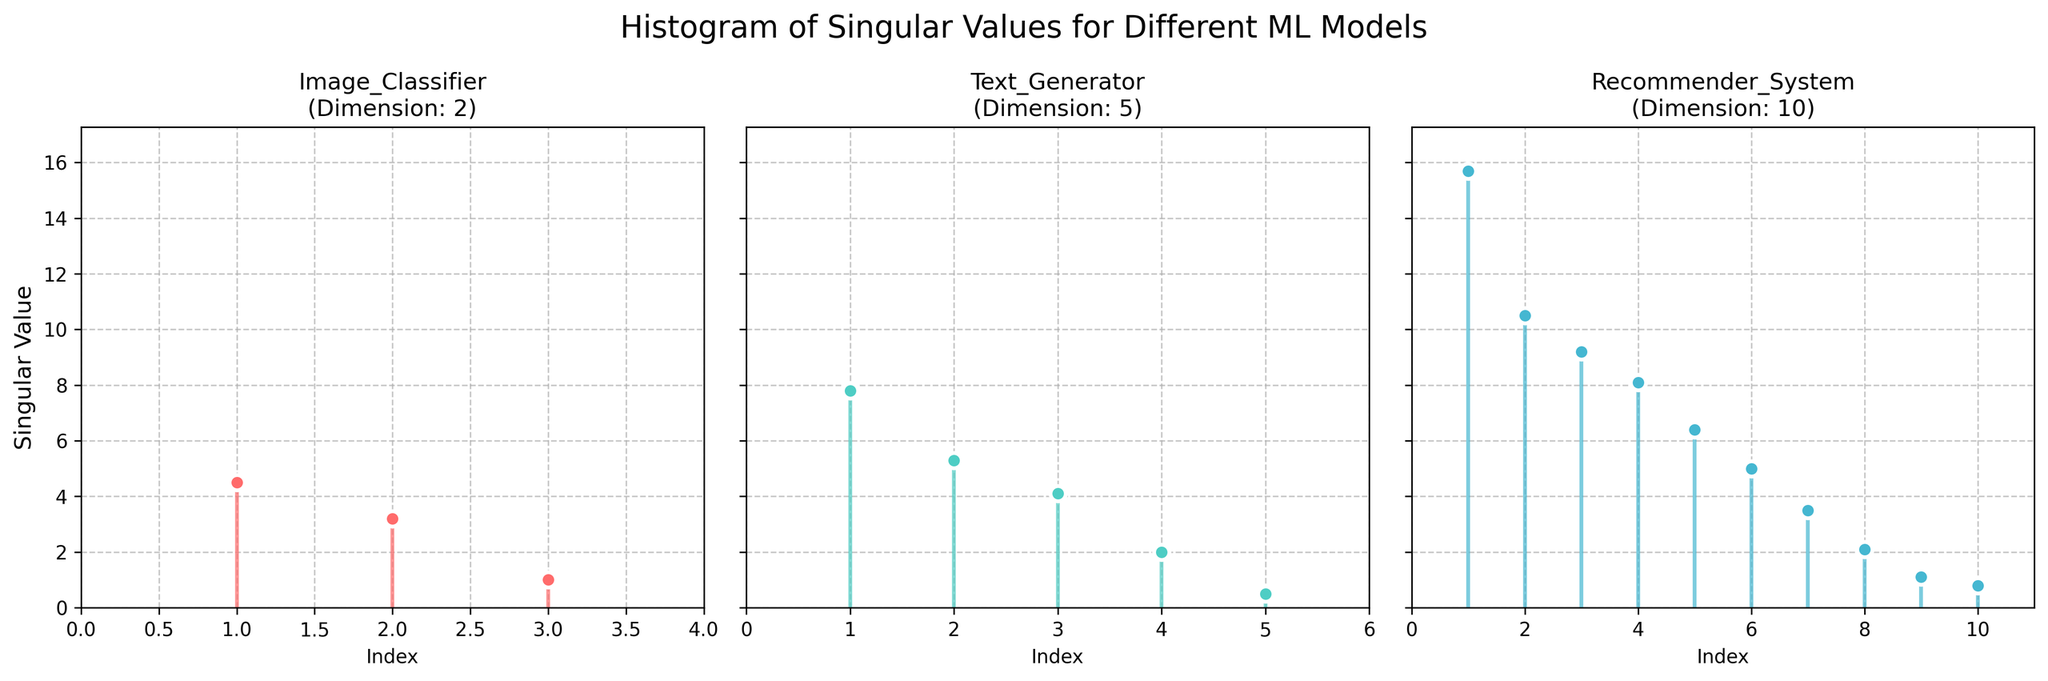what is the title of the figure? The title is usually displayed at the top of the figure. In this case, the title is 'Histogram of Singular Values for Different ML Models'.
Answer: Histogram of Singular Values for Different ML Models How many subplots are there in the figure? The figure is divided into three sections, each representing different ML models. Each section is a subplot.
Answer: 3 What are the entities represented in the figure? The entities are mentioned in the title of each subplot. They include 'Image_Classifier', 'Text_Generator', and 'Recommender_System'.
Answer: Image_Classifier, Text_Generator, Recommender_System For the 'Image_Classifier' entity, what is the dimension displayed? The dimension is indicated in the title of the subplot for 'Image_Classifier', which reads 'Dimension: 2'.
Answer: 2 Which entity has the highest singular value? By comparing the highest peaks in each subplot, the 'Recommender_System' entity has the highest singular value of 15.7.
Answer: Recommender_System What is the smallest singular value for 'Text_Generator'? The stem plot for 'Text_Generator' shows the smallest singular value as one of the stems' height, which is 0.5.
Answer: 0.5 Which subplot represents the entity with the most singular values? By counting the stems in each subplot, the 'Recommender_System' entity has the most singular values with 10 data points.
Answer: Recommender_System What is the sum of the singular values for 'Image_Classifier'? Summing the singular values shown in the 'Image_Classifier' subplot: 4.5 + 3.2 + 1.0 equals 8.7.
Answer: 8.7 What is the average singular value for 'Text_Generator'? Adding the singular values: 7.8 + 5.3 + 4.1 + 2.0 + 0.5 equals 19.7. Then dividing by the number of values (5) gives: 19.7 / 5 equals 3.94.
Answer: 3.94 Compare the third singular values of 'Image_Classifier' and 'Recommender_System'. Which one is greater? The third singular value for 'Image_Classifier' is 1.0, and for 'Recommender_System' it is 9.2. Hence, 9.2 is greater than 1.0.
Answer: Recommender_System 